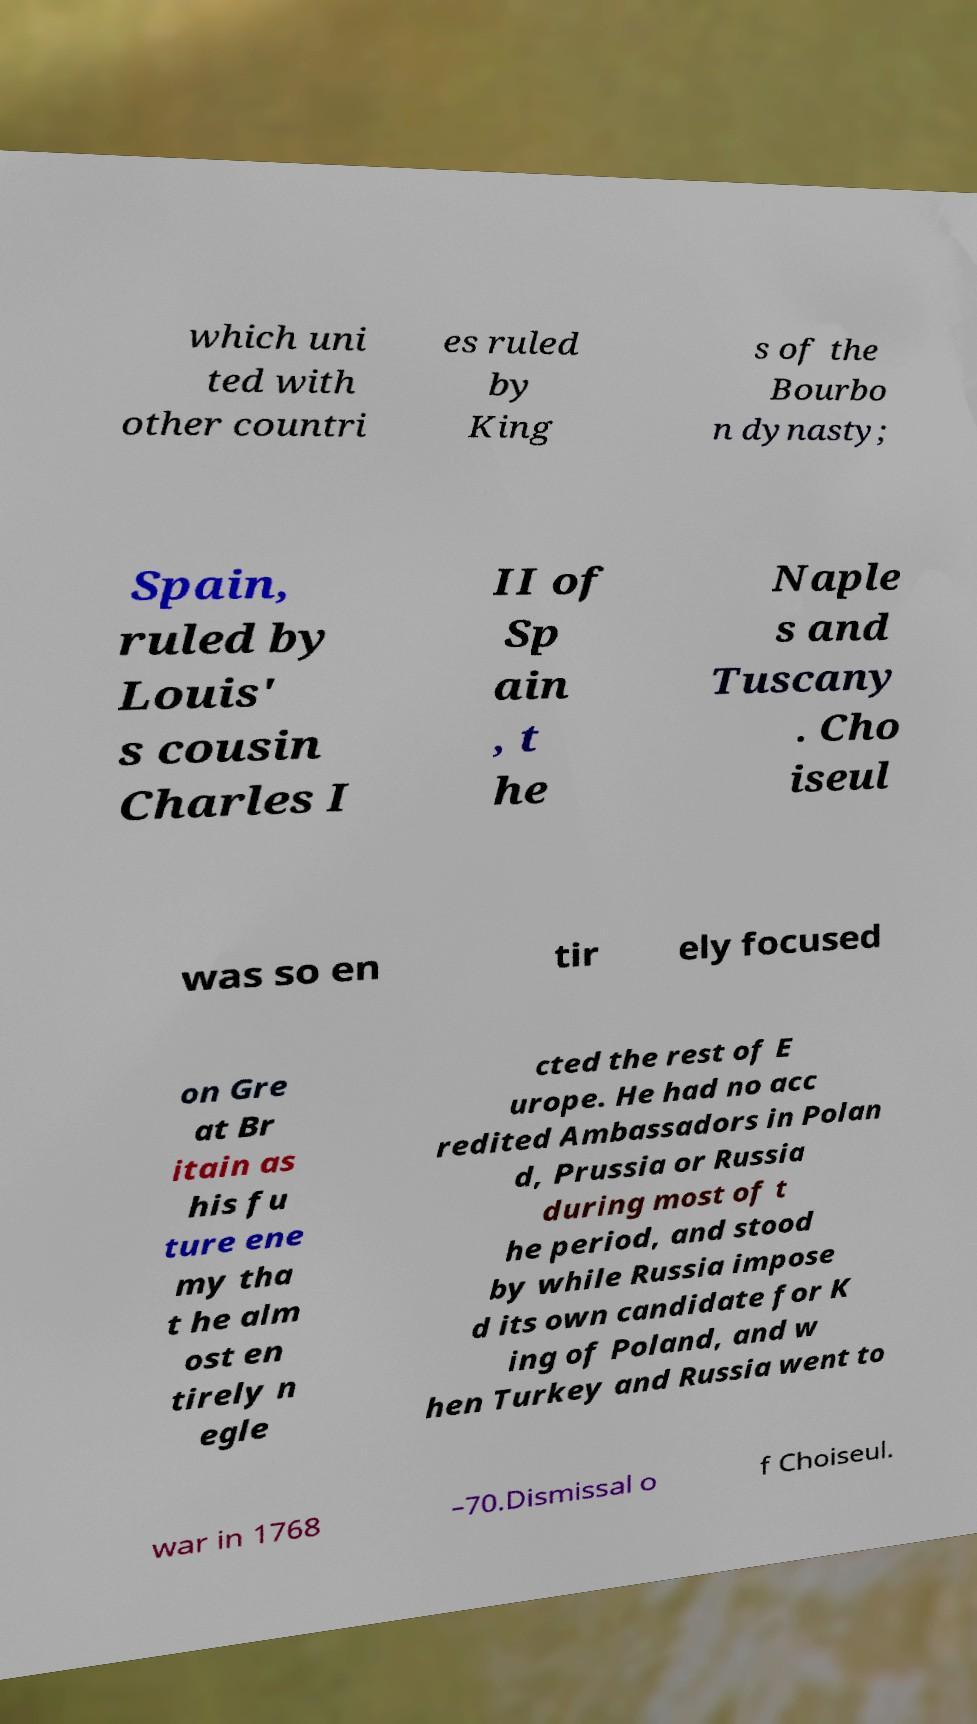Could you extract and type out the text from this image? which uni ted with other countri es ruled by King s of the Bourbo n dynasty; Spain, ruled by Louis' s cousin Charles I II of Sp ain , t he Naple s and Tuscany . Cho iseul was so en tir ely focused on Gre at Br itain as his fu ture ene my tha t he alm ost en tirely n egle cted the rest of E urope. He had no acc redited Ambassadors in Polan d, Prussia or Russia during most of t he period, and stood by while Russia impose d its own candidate for K ing of Poland, and w hen Turkey and Russia went to war in 1768 –70.Dismissal o f Choiseul. 